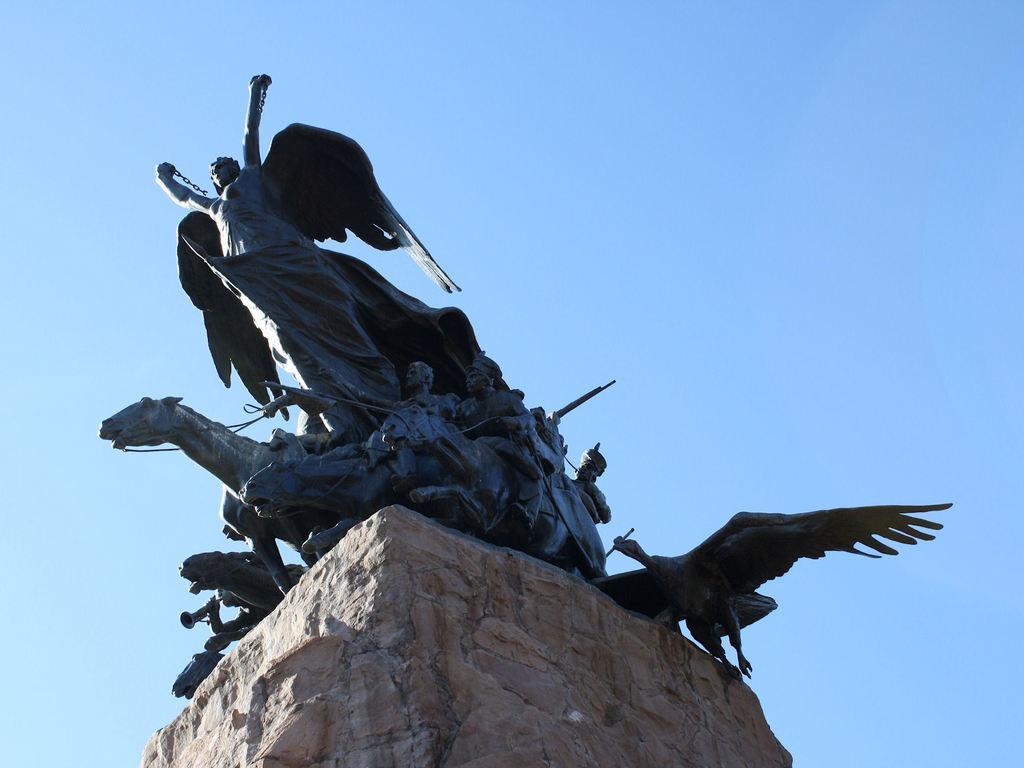Could you give a brief overview of what you see in this image? In this image I can see a statue of few persons and few animals which is black in color on the rock which is brown in color and in the background I can see the sky. 